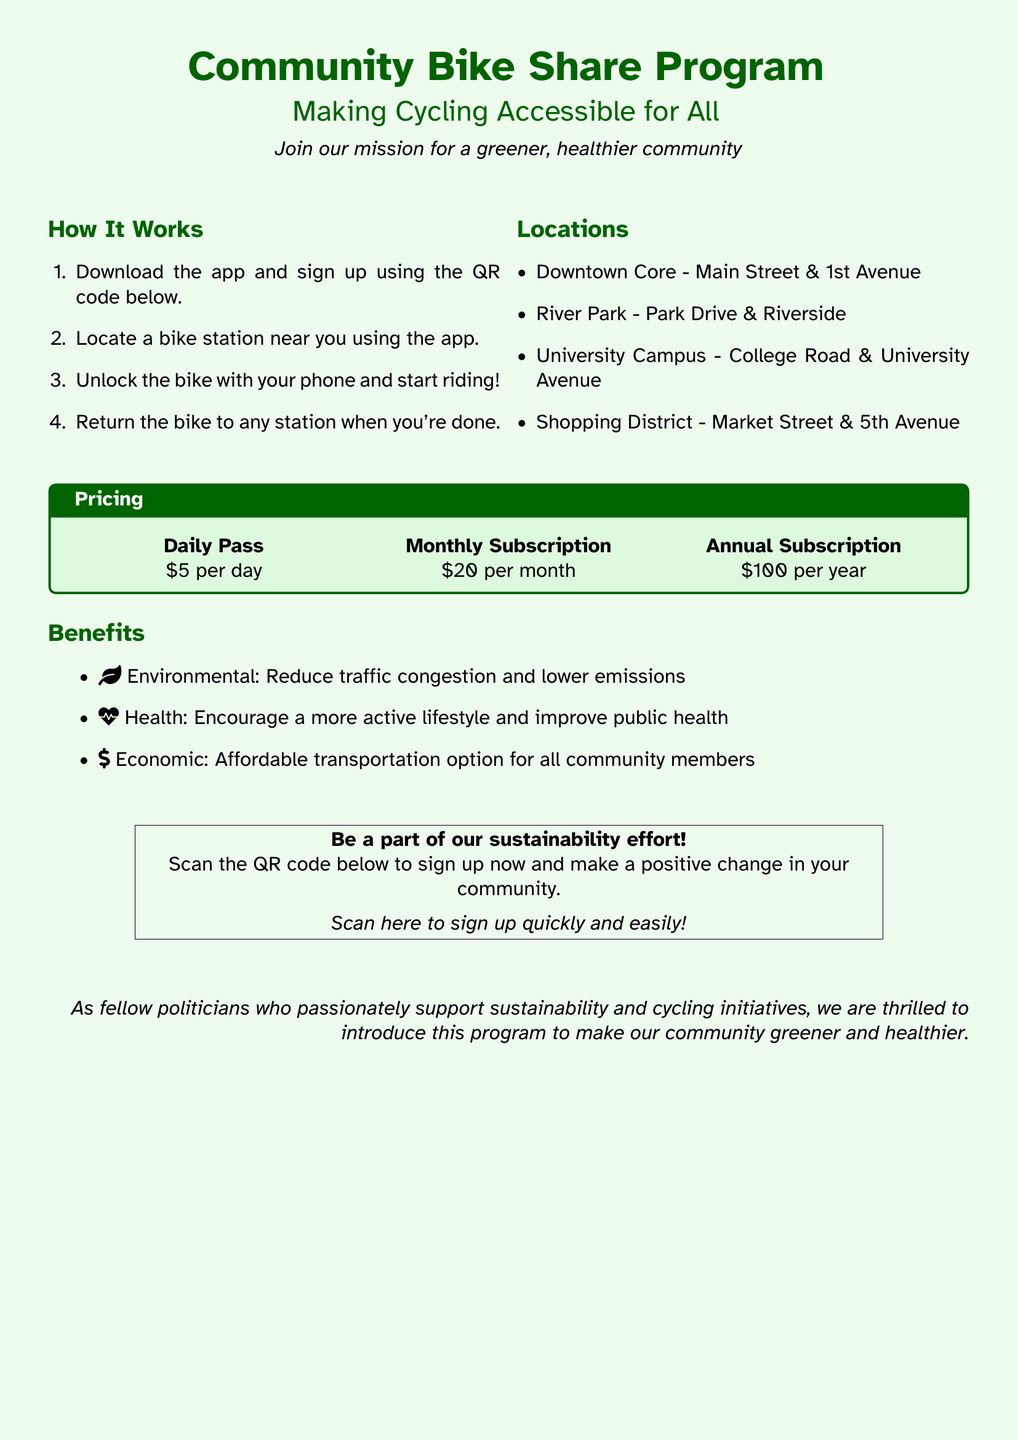What is the title of the program? The title is clearly stated at the top of the flyer as "Community Bike Share Program."
Answer: Community Bike Share Program How much is the daily pass? The daily pass pricing is specified in the pricing section of the flyer as $5 per day.
Answer: $5 per day Where is the River Park bike station located? The document lists locations including "Park Drive & Riverside" for the River Park station.
Answer: Park Drive & Riverside What are the health benefits mentioned? Health benefits focus on encouraging an active lifestyle and improving public health, elaborated under the benefits section.
Answer: Encourage a more active lifestyle and improve public health What is the price of the annual subscription? The annual subscription price is stated directly in the pricing section as $100 per year.
Answer: $100 per year What is the primary environmental benefit listed? The environmental benefit highlighted is "Reduce traffic congestion and lower emissions."
Answer: Reduce traffic congestion and lower emissions How can users sign up for the program? Users can sign up by scanning the QR code mentioned in the flyer, providing a quick and easy process.
Answer: Scan the QR code What are the two main community goals of this program? The goals underline making the community greener and healthier, elaborated in the introductory statement.
Answer: Greener and healthier community What type of document is this? The document is a flyer informing the public about a community initiative, specifically detailing the bike share program.
Answer: Flyer 